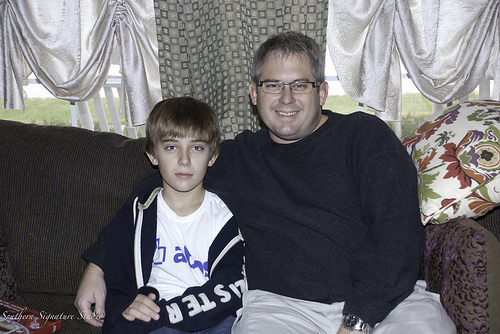<image>
Is the father to the right of the boy? Yes. From this viewpoint, the father is positioned to the right side relative to the boy. Where is the fabric in relation to the pillow? Is it in the pillow? Yes. The fabric is contained within or inside the pillow, showing a containment relationship. 